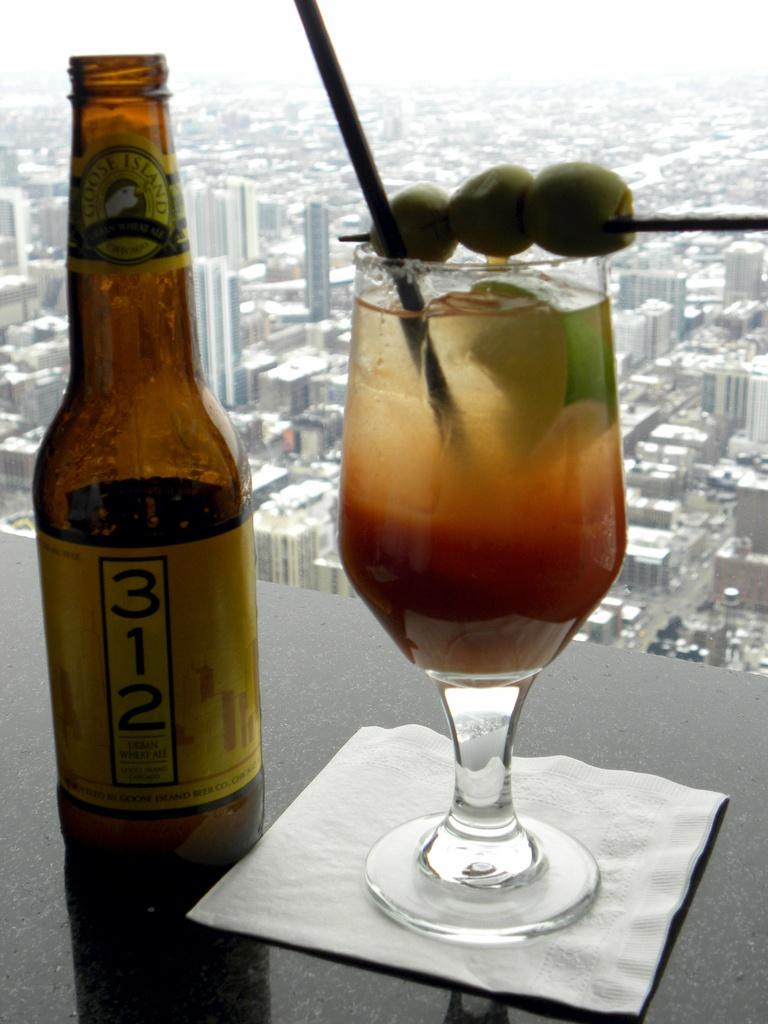<image>
Summarize the visual content of the image. Bottle of 312 next to a cup of alcohol. 